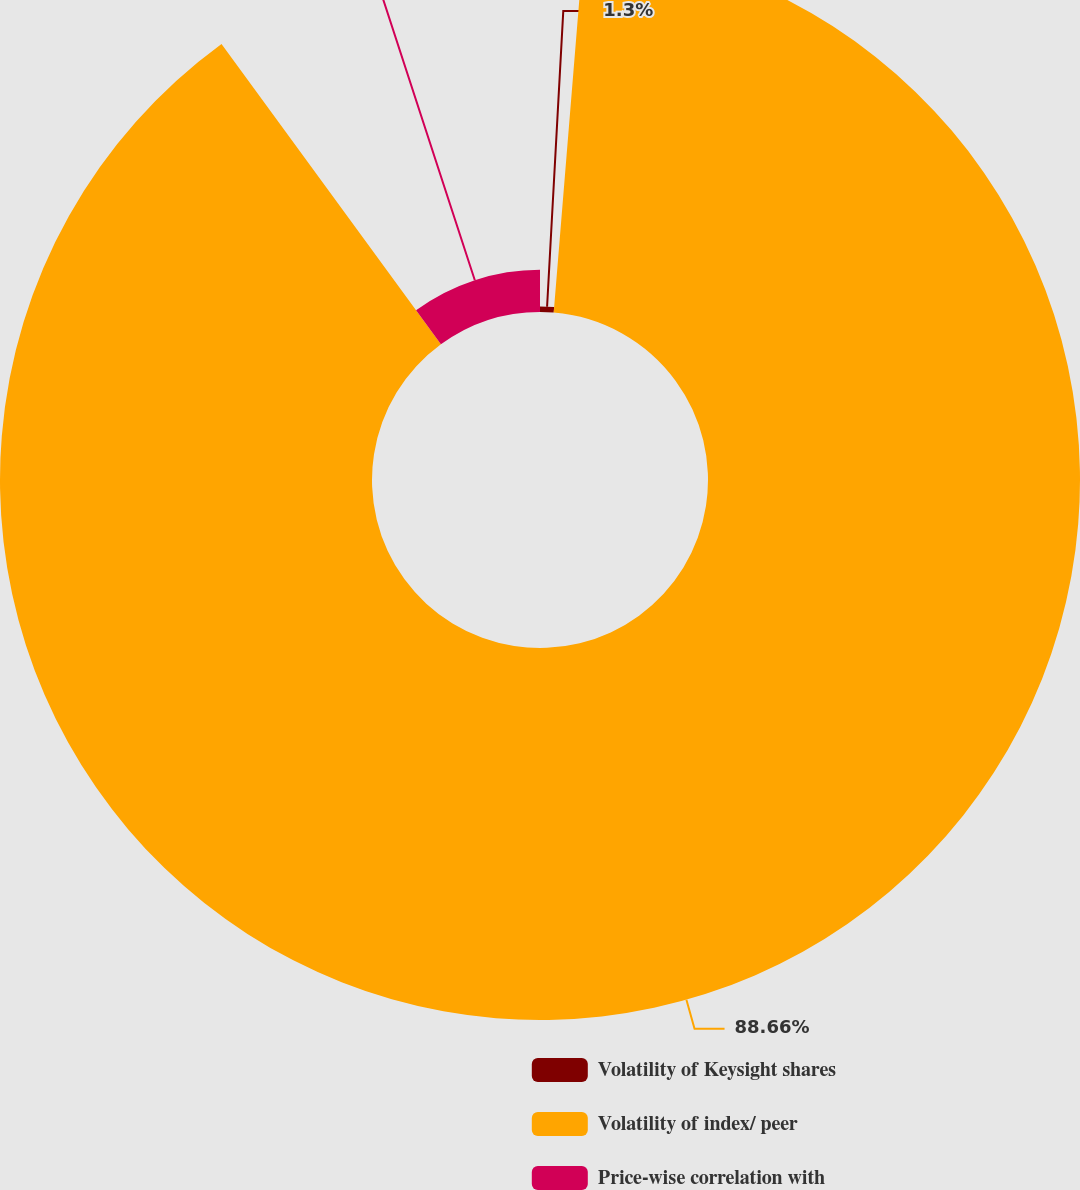Convert chart. <chart><loc_0><loc_0><loc_500><loc_500><pie_chart><fcel>Volatility of Keysight shares<fcel>Volatility of index/ peer<fcel>Price-wise correlation with<nl><fcel>1.3%<fcel>88.66%<fcel>10.04%<nl></chart> 